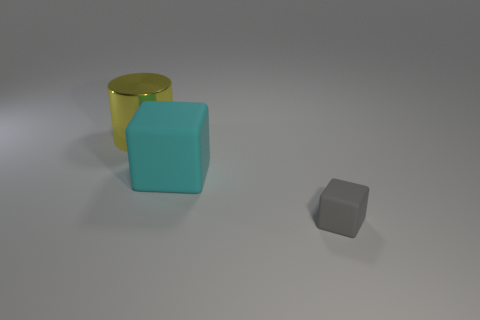Are there any other things that are the same size as the gray rubber object?
Provide a succinct answer. No. Are there any other things that have the same shape as the yellow thing?
Your response must be concise. No. How many spheres are tiny objects or big yellow metal things?
Your answer should be compact. 0. How many large cyan metal blocks are there?
Your response must be concise. 0. How big is the matte cube that is in front of the large object that is in front of the large metallic thing?
Your response must be concise. Small. What number of other things are there of the same size as the shiny thing?
Your response must be concise. 1. What number of matte things are right of the large rubber thing?
Your answer should be compact. 1. The yellow metallic object has what size?
Make the answer very short. Large. Is the large thing that is right of the yellow shiny cylinder made of the same material as the big yellow cylinder that is behind the tiny rubber thing?
Provide a succinct answer. No. There is a block that is the same size as the yellow cylinder; what is its color?
Keep it short and to the point. Cyan. 